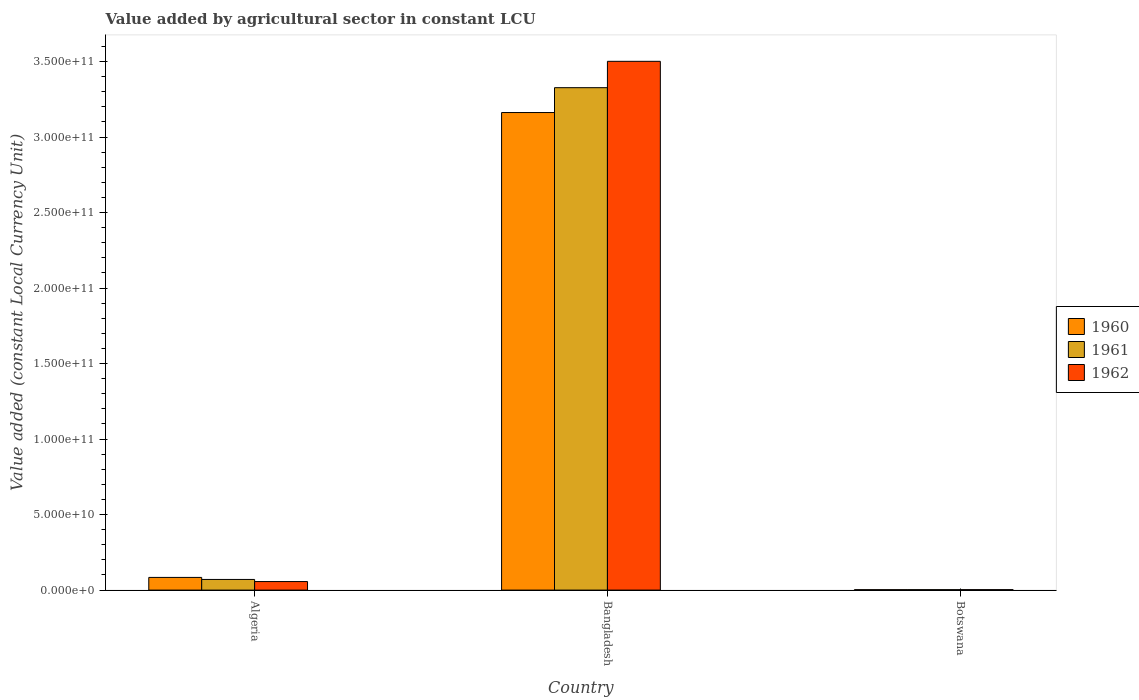How many different coloured bars are there?
Provide a short and direct response. 3. Are the number of bars per tick equal to the number of legend labels?
Ensure brevity in your answer.  Yes. Are the number of bars on each tick of the X-axis equal?
Keep it short and to the point. Yes. How many bars are there on the 1st tick from the right?
Your answer should be very brief. 3. What is the label of the 1st group of bars from the left?
Provide a succinct answer. Algeria. In how many cases, is the number of bars for a given country not equal to the number of legend labels?
Ensure brevity in your answer.  0. What is the value added by agricultural sector in 1961 in Bangladesh?
Make the answer very short. 3.33e+11. Across all countries, what is the maximum value added by agricultural sector in 1960?
Provide a succinct answer. 3.16e+11. Across all countries, what is the minimum value added by agricultural sector in 1961?
Your answer should be compact. 2.86e+08. In which country was the value added by agricultural sector in 1960 maximum?
Provide a short and direct response. Bangladesh. In which country was the value added by agricultural sector in 1961 minimum?
Your answer should be compact. Botswana. What is the total value added by agricultural sector in 1960 in the graph?
Provide a short and direct response. 3.25e+11. What is the difference between the value added by agricultural sector in 1961 in Algeria and that in Bangladesh?
Give a very brief answer. -3.26e+11. What is the difference between the value added by agricultural sector in 1961 in Algeria and the value added by agricultural sector in 1962 in Bangladesh?
Make the answer very short. -3.43e+11. What is the average value added by agricultural sector in 1961 per country?
Keep it short and to the point. 1.13e+11. What is the difference between the value added by agricultural sector of/in 1962 and value added by agricultural sector of/in 1960 in Bangladesh?
Offer a terse response. 3.39e+1. What is the ratio of the value added by agricultural sector in 1962 in Bangladesh to that in Botswana?
Provide a short and direct response. 1181.56. Is the value added by agricultural sector in 1962 in Algeria less than that in Bangladesh?
Offer a very short reply. Yes. Is the difference between the value added by agricultural sector in 1962 in Algeria and Bangladesh greater than the difference between the value added by agricultural sector in 1960 in Algeria and Bangladesh?
Ensure brevity in your answer.  No. What is the difference between the highest and the second highest value added by agricultural sector in 1960?
Offer a very short reply. 3.16e+11. What is the difference between the highest and the lowest value added by agricultural sector in 1960?
Offer a very short reply. 3.16e+11. In how many countries, is the value added by agricultural sector in 1960 greater than the average value added by agricultural sector in 1960 taken over all countries?
Make the answer very short. 1. What does the 2nd bar from the left in Bangladesh represents?
Make the answer very short. 1961. What does the 3rd bar from the right in Botswana represents?
Offer a very short reply. 1960. Is it the case that in every country, the sum of the value added by agricultural sector in 1961 and value added by agricultural sector in 1960 is greater than the value added by agricultural sector in 1962?
Your response must be concise. Yes. How many bars are there?
Provide a succinct answer. 9. How many countries are there in the graph?
Offer a very short reply. 3. What is the title of the graph?
Your response must be concise. Value added by agricultural sector in constant LCU. What is the label or title of the Y-axis?
Your response must be concise. Value added (constant Local Currency Unit). What is the Value added (constant Local Currency Unit) of 1960 in Algeria?
Give a very brief answer. 8.40e+09. What is the Value added (constant Local Currency Unit) of 1961 in Algeria?
Your answer should be very brief. 7.05e+09. What is the Value added (constant Local Currency Unit) in 1962 in Algeria?
Keep it short and to the point. 5.66e+09. What is the Value added (constant Local Currency Unit) of 1960 in Bangladesh?
Keep it short and to the point. 3.16e+11. What is the Value added (constant Local Currency Unit) of 1961 in Bangladesh?
Offer a terse response. 3.33e+11. What is the Value added (constant Local Currency Unit) in 1962 in Bangladesh?
Your answer should be very brief. 3.50e+11. What is the Value added (constant Local Currency Unit) of 1960 in Botswana?
Your answer should be compact. 2.79e+08. What is the Value added (constant Local Currency Unit) of 1961 in Botswana?
Your answer should be compact. 2.86e+08. What is the Value added (constant Local Currency Unit) of 1962 in Botswana?
Ensure brevity in your answer.  2.96e+08. Across all countries, what is the maximum Value added (constant Local Currency Unit) in 1960?
Make the answer very short. 3.16e+11. Across all countries, what is the maximum Value added (constant Local Currency Unit) of 1961?
Make the answer very short. 3.33e+11. Across all countries, what is the maximum Value added (constant Local Currency Unit) in 1962?
Your answer should be very brief. 3.50e+11. Across all countries, what is the minimum Value added (constant Local Currency Unit) of 1960?
Your response must be concise. 2.79e+08. Across all countries, what is the minimum Value added (constant Local Currency Unit) of 1961?
Ensure brevity in your answer.  2.86e+08. Across all countries, what is the minimum Value added (constant Local Currency Unit) of 1962?
Provide a short and direct response. 2.96e+08. What is the total Value added (constant Local Currency Unit) of 1960 in the graph?
Your response must be concise. 3.25e+11. What is the total Value added (constant Local Currency Unit) in 1961 in the graph?
Make the answer very short. 3.40e+11. What is the total Value added (constant Local Currency Unit) in 1962 in the graph?
Your answer should be very brief. 3.56e+11. What is the difference between the Value added (constant Local Currency Unit) in 1960 in Algeria and that in Bangladesh?
Offer a very short reply. -3.08e+11. What is the difference between the Value added (constant Local Currency Unit) of 1961 in Algeria and that in Bangladesh?
Your answer should be very brief. -3.26e+11. What is the difference between the Value added (constant Local Currency Unit) of 1962 in Algeria and that in Bangladesh?
Make the answer very short. -3.44e+11. What is the difference between the Value added (constant Local Currency Unit) in 1960 in Algeria and that in Botswana?
Make the answer very short. 8.12e+09. What is the difference between the Value added (constant Local Currency Unit) of 1961 in Algeria and that in Botswana?
Provide a succinct answer. 6.77e+09. What is the difference between the Value added (constant Local Currency Unit) in 1962 in Algeria and that in Botswana?
Provide a succinct answer. 5.36e+09. What is the difference between the Value added (constant Local Currency Unit) of 1960 in Bangladesh and that in Botswana?
Offer a terse response. 3.16e+11. What is the difference between the Value added (constant Local Currency Unit) of 1961 in Bangladesh and that in Botswana?
Your answer should be compact. 3.32e+11. What is the difference between the Value added (constant Local Currency Unit) in 1962 in Bangladesh and that in Botswana?
Provide a short and direct response. 3.50e+11. What is the difference between the Value added (constant Local Currency Unit) in 1960 in Algeria and the Value added (constant Local Currency Unit) in 1961 in Bangladesh?
Give a very brief answer. -3.24e+11. What is the difference between the Value added (constant Local Currency Unit) of 1960 in Algeria and the Value added (constant Local Currency Unit) of 1962 in Bangladesh?
Your response must be concise. -3.42e+11. What is the difference between the Value added (constant Local Currency Unit) of 1961 in Algeria and the Value added (constant Local Currency Unit) of 1962 in Bangladesh?
Your answer should be compact. -3.43e+11. What is the difference between the Value added (constant Local Currency Unit) of 1960 in Algeria and the Value added (constant Local Currency Unit) of 1961 in Botswana?
Offer a very short reply. 8.11e+09. What is the difference between the Value added (constant Local Currency Unit) in 1960 in Algeria and the Value added (constant Local Currency Unit) in 1962 in Botswana?
Provide a succinct answer. 8.10e+09. What is the difference between the Value added (constant Local Currency Unit) of 1961 in Algeria and the Value added (constant Local Currency Unit) of 1962 in Botswana?
Your response must be concise. 6.76e+09. What is the difference between the Value added (constant Local Currency Unit) in 1960 in Bangladesh and the Value added (constant Local Currency Unit) in 1961 in Botswana?
Your answer should be compact. 3.16e+11. What is the difference between the Value added (constant Local Currency Unit) in 1960 in Bangladesh and the Value added (constant Local Currency Unit) in 1962 in Botswana?
Provide a short and direct response. 3.16e+11. What is the difference between the Value added (constant Local Currency Unit) of 1961 in Bangladesh and the Value added (constant Local Currency Unit) of 1962 in Botswana?
Keep it short and to the point. 3.32e+11. What is the average Value added (constant Local Currency Unit) in 1960 per country?
Keep it short and to the point. 1.08e+11. What is the average Value added (constant Local Currency Unit) of 1961 per country?
Your answer should be compact. 1.13e+11. What is the average Value added (constant Local Currency Unit) in 1962 per country?
Provide a succinct answer. 1.19e+11. What is the difference between the Value added (constant Local Currency Unit) of 1960 and Value added (constant Local Currency Unit) of 1961 in Algeria?
Make the answer very short. 1.35e+09. What is the difference between the Value added (constant Local Currency Unit) of 1960 and Value added (constant Local Currency Unit) of 1962 in Algeria?
Ensure brevity in your answer.  2.74e+09. What is the difference between the Value added (constant Local Currency Unit) in 1961 and Value added (constant Local Currency Unit) in 1962 in Algeria?
Ensure brevity in your answer.  1.40e+09. What is the difference between the Value added (constant Local Currency Unit) of 1960 and Value added (constant Local Currency Unit) of 1961 in Bangladesh?
Offer a very short reply. -1.65e+1. What is the difference between the Value added (constant Local Currency Unit) of 1960 and Value added (constant Local Currency Unit) of 1962 in Bangladesh?
Offer a very short reply. -3.39e+1. What is the difference between the Value added (constant Local Currency Unit) in 1961 and Value added (constant Local Currency Unit) in 1962 in Bangladesh?
Keep it short and to the point. -1.75e+1. What is the difference between the Value added (constant Local Currency Unit) of 1960 and Value added (constant Local Currency Unit) of 1961 in Botswana?
Your answer should be very brief. -6.88e+06. What is the difference between the Value added (constant Local Currency Unit) of 1960 and Value added (constant Local Currency Unit) of 1962 in Botswana?
Ensure brevity in your answer.  -1.72e+07. What is the difference between the Value added (constant Local Currency Unit) of 1961 and Value added (constant Local Currency Unit) of 1962 in Botswana?
Your answer should be compact. -1.03e+07. What is the ratio of the Value added (constant Local Currency Unit) of 1960 in Algeria to that in Bangladesh?
Keep it short and to the point. 0.03. What is the ratio of the Value added (constant Local Currency Unit) of 1961 in Algeria to that in Bangladesh?
Provide a short and direct response. 0.02. What is the ratio of the Value added (constant Local Currency Unit) of 1962 in Algeria to that in Bangladesh?
Provide a succinct answer. 0.02. What is the ratio of the Value added (constant Local Currency Unit) in 1960 in Algeria to that in Botswana?
Your answer should be very brief. 30.08. What is the ratio of the Value added (constant Local Currency Unit) of 1961 in Algeria to that in Botswana?
Give a very brief answer. 24.65. What is the ratio of the Value added (constant Local Currency Unit) of 1962 in Algeria to that in Botswana?
Your response must be concise. 19.09. What is the ratio of the Value added (constant Local Currency Unit) in 1960 in Bangladesh to that in Botswana?
Offer a terse response. 1132.8. What is the ratio of the Value added (constant Local Currency Unit) of 1961 in Bangladesh to that in Botswana?
Provide a succinct answer. 1163.15. What is the ratio of the Value added (constant Local Currency Unit) in 1962 in Bangladesh to that in Botswana?
Provide a succinct answer. 1181.56. What is the difference between the highest and the second highest Value added (constant Local Currency Unit) of 1960?
Provide a succinct answer. 3.08e+11. What is the difference between the highest and the second highest Value added (constant Local Currency Unit) of 1961?
Provide a short and direct response. 3.26e+11. What is the difference between the highest and the second highest Value added (constant Local Currency Unit) in 1962?
Your response must be concise. 3.44e+11. What is the difference between the highest and the lowest Value added (constant Local Currency Unit) of 1960?
Keep it short and to the point. 3.16e+11. What is the difference between the highest and the lowest Value added (constant Local Currency Unit) of 1961?
Your response must be concise. 3.32e+11. What is the difference between the highest and the lowest Value added (constant Local Currency Unit) in 1962?
Provide a succinct answer. 3.50e+11. 